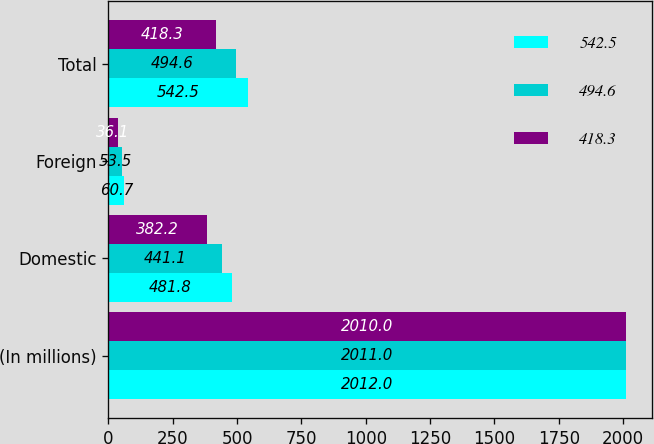Convert chart. <chart><loc_0><loc_0><loc_500><loc_500><stacked_bar_chart><ecel><fcel>(In millions)<fcel>Domestic<fcel>Foreign<fcel>Total<nl><fcel>542.5<fcel>2012<fcel>481.8<fcel>60.7<fcel>542.5<nl><fcel>494.6<fcel>2011<fcel>441.1<fcel>53.5<fcel>494.6<nl><fcel>418.3<fcel>2010<fcel>382.2<fcel>36.1<fcel>418.3<nl></chart> 